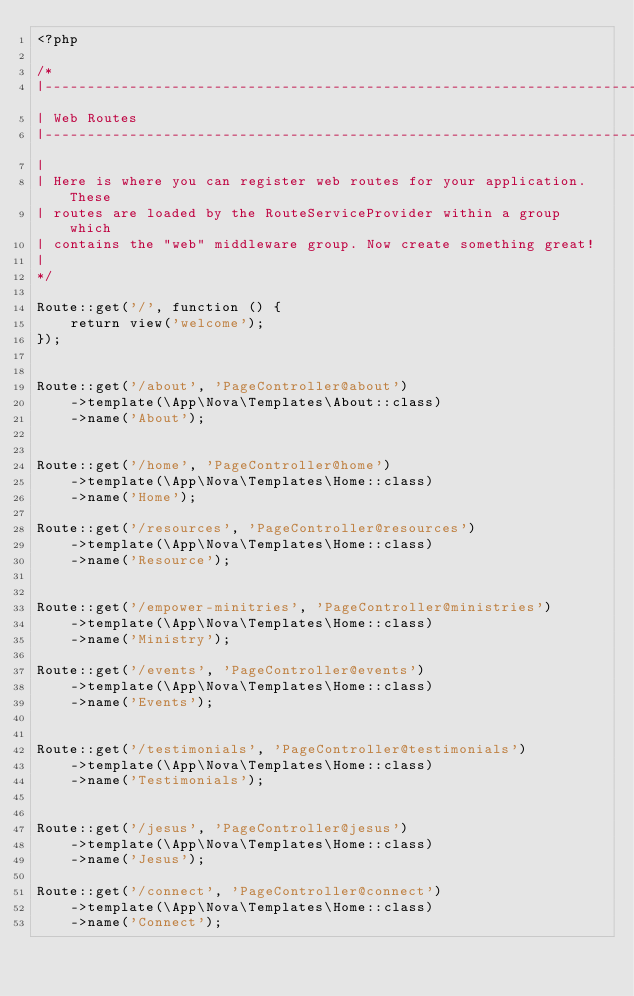<code> <loc_0><loc_0><loc_500><loc_500><_PHP_><?php

/*
|--------------------------------------------------------------------------
| Web Routes
|--------------------------------------------------------------------------
|
| Here is where you can register web routes for your application. These
| routes are loaded by the RouteServiceProvider within a group which
| contains the "web" middleware group. Now create something great!
|
*/

Route::get('/', function () {
    return view('welcome');
});


Route::get('/about', 'PageController@about')
    ->template(\App\Nova\Templates\About::class)
    ->name('About');


Route::get('/home', 'PageController@home')
    ->template(\App\Nova\Templates\Home::class)
    ->name('Home');

Route::get('/resources', 'PageController@resources')
    ->template(\App\Nova\Templates\Home::class)
    ->name('Resource');


Route::get('/empower-minitries', 'PageController@ministries')
    ->template(\App\Nova\Templates\Home::class)
    ->name('Ministry');

Route::get('/events', 'PageController@events')
    ->template(\App\Nova\Templates\Home::class)
    ->name('Events');


Route::get('/testimonials', 'PageController@testimonials')
    ->template(\App\Nova\Templates\Home::class)
    ->name('Testimonials');


Route::get('/jesus', 'PageController@jesus')
    ->template(\App\Nova\Templates\Home::class)
    ->name('Jesus');

Route::get('/connect', 'PageController@connect')
    ->template(\App\Nova\Templates\Home::class)
    ->name('Connect');</code> 